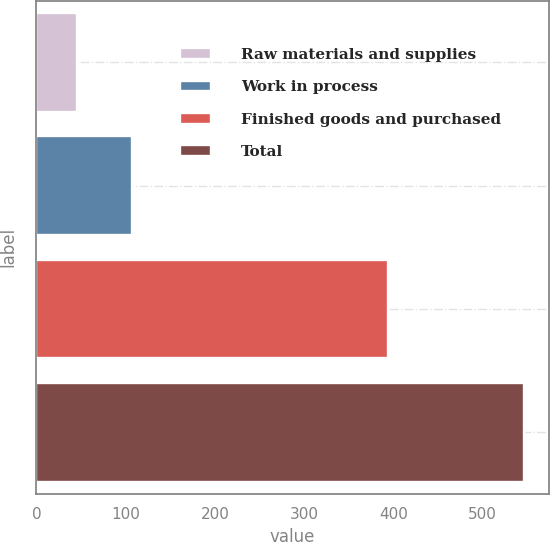Convert chart. <chart><loc_0><loc_0><loc_500><loc_500><bar_chart><fcel>Raw materials and supplies<fcel>Work in process<fcel>Finished goods and purchased<fcel>Total<nl><fcel>45.4<fcel>107.7<fcel>393.6<fcel>546.7<nl></chart> 